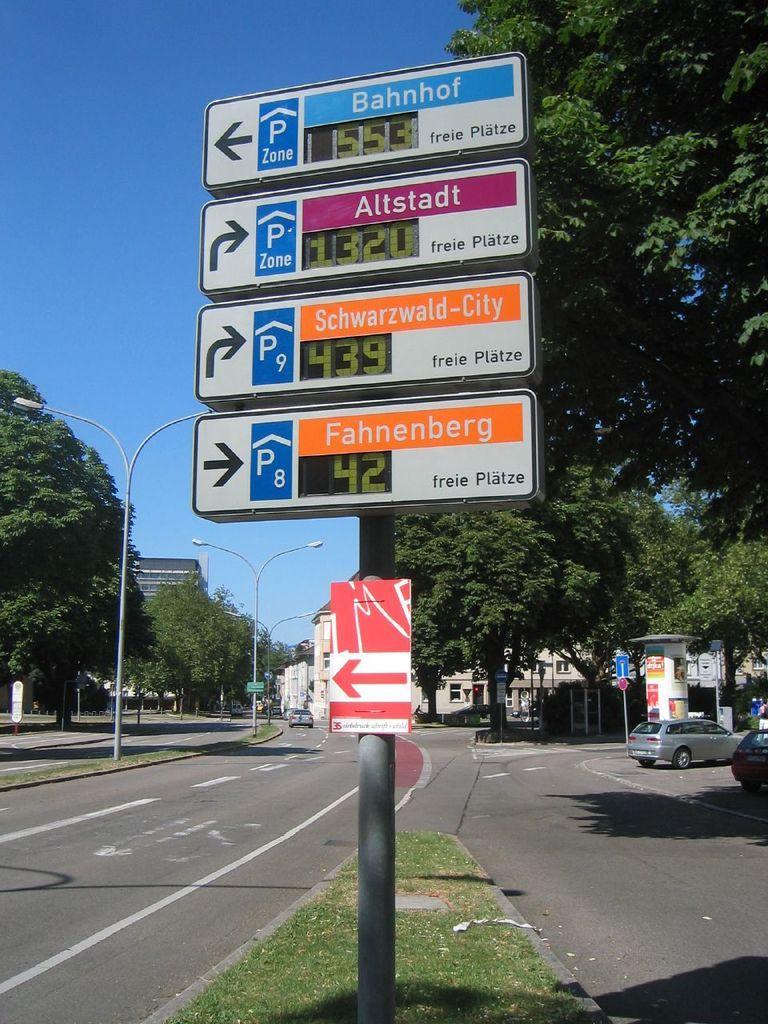Describe this image in one or two sentences. In this image I can see a pole which has boards attached to it. In the background I can see a building, trees, vehicles on roads, street lights, the sky and the grass. 